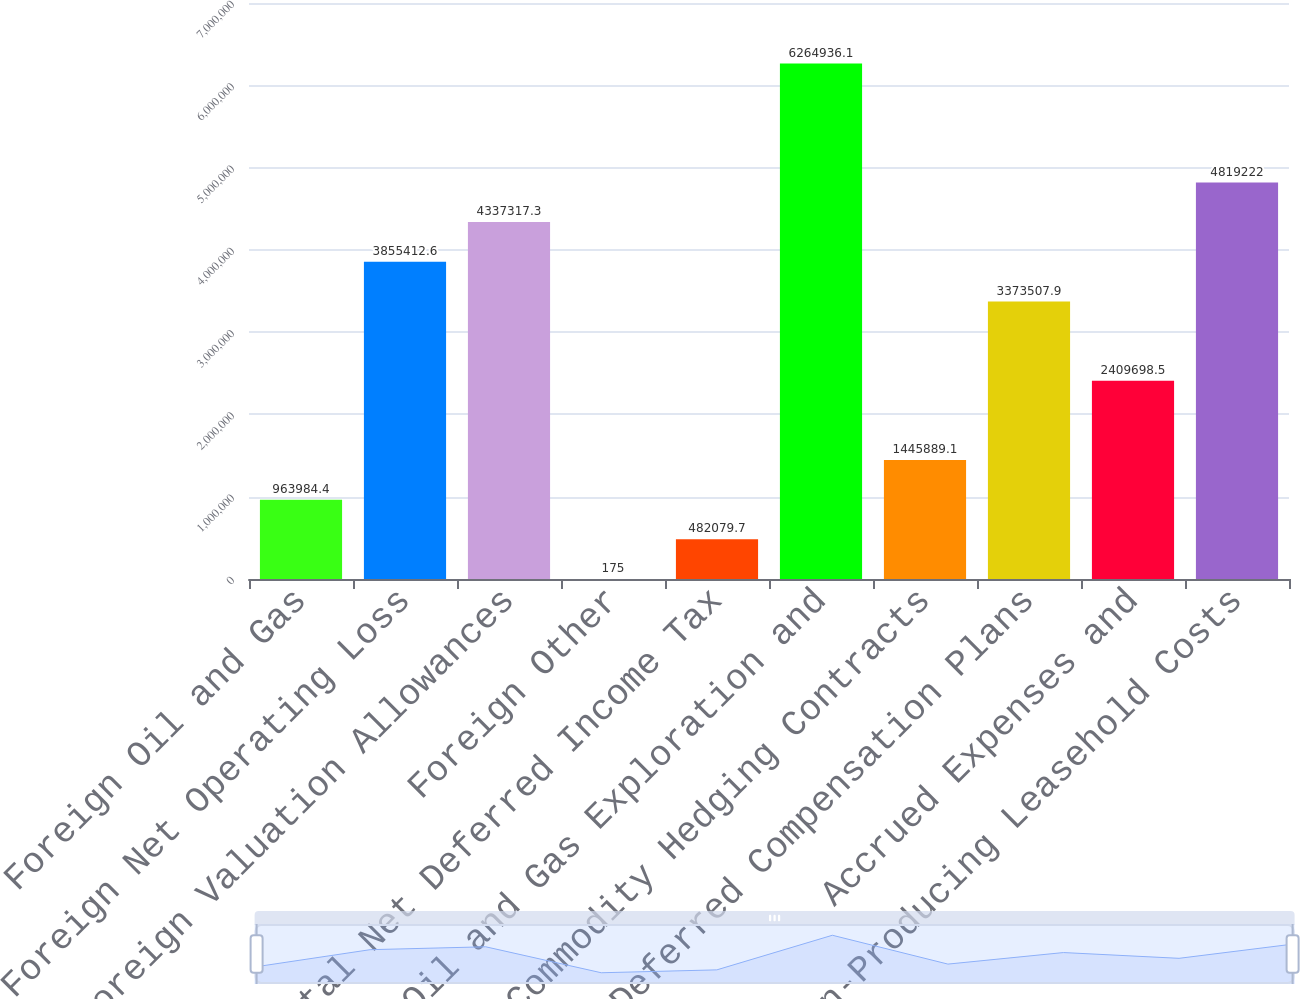Convert chart to OTSL. <chart><loc_0><loc_0><loc_500><loc_500><bar_chart><fcel>Foreign Oil and Gas<fcel>Foreign Net Operating Loss<fcel>Foreign Valuation Allowances<fcel>Foreign Other<fcel>Total Net Deferred Income Tax<fcel>Oil and Gas Exploration and<fcel>Commodity Hedging Contracts<fcel>Deferred Compensation Plans<fcel>Accrued Expenses and<fcel>Non-Producing Leasehold Costs<nl><fcel>963984<fcel>3.85541e+06<fcel>4.33732e+06<fcel>175<fcel>482080<fcel>6.26494e+06<fcel>1.44589e+06<fcel>3.37351e+06<fcel>2.4097e+06<fcel>4.81922e+06<nl></chart> 